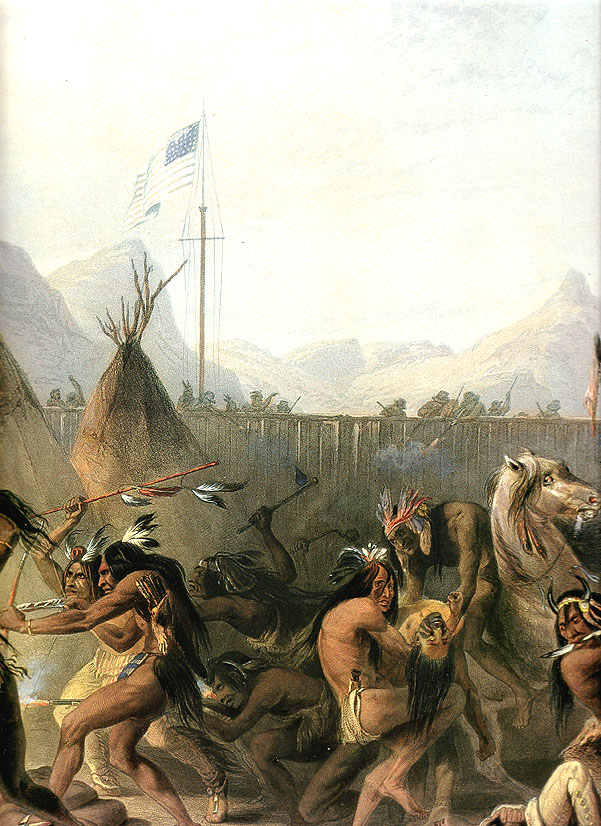How does the presence of the American flag influence your interpretation of the scene? The presence of the American flag adds a layer of complexity and historical context to the scene. It suggests a time of transition, where Indigenous cultures were coming into contact with European settlers. This juxtaposition of Native American traditions with the symbol of the United States flag could indicate either a moment of cooperation or tension between the two cultures. The flag might represent the imposition of new governance and societal changes on the Native American way of life, or it could highlight a period of negotiated peace and cultural exchange. This duality introduces a thought-provoking narrative about identity, resilience, and the intersection of different cultural histories. If you could change one element in the painting to alter its historical narrative, what would it be and why? If I could change one element in the painting to alter its historical narrative, it would be to replace the solitary American flag with a blend of symbols from both Native American and American cultures. For instance, adding a totem pole alongside the flagpole could symbolize a more harmonious coexistence and mutual respect. This alteration would shift the focus from a potential colonial narrative to one that emphasizes cultural exchange and unity. It would enhance the narrative to reflect a shared history and the collaborative efforts to build a cohesive, integrated community, maintaining the cultural identity and traditions of the Native American people while acknowledging the presence of the new settlers. 